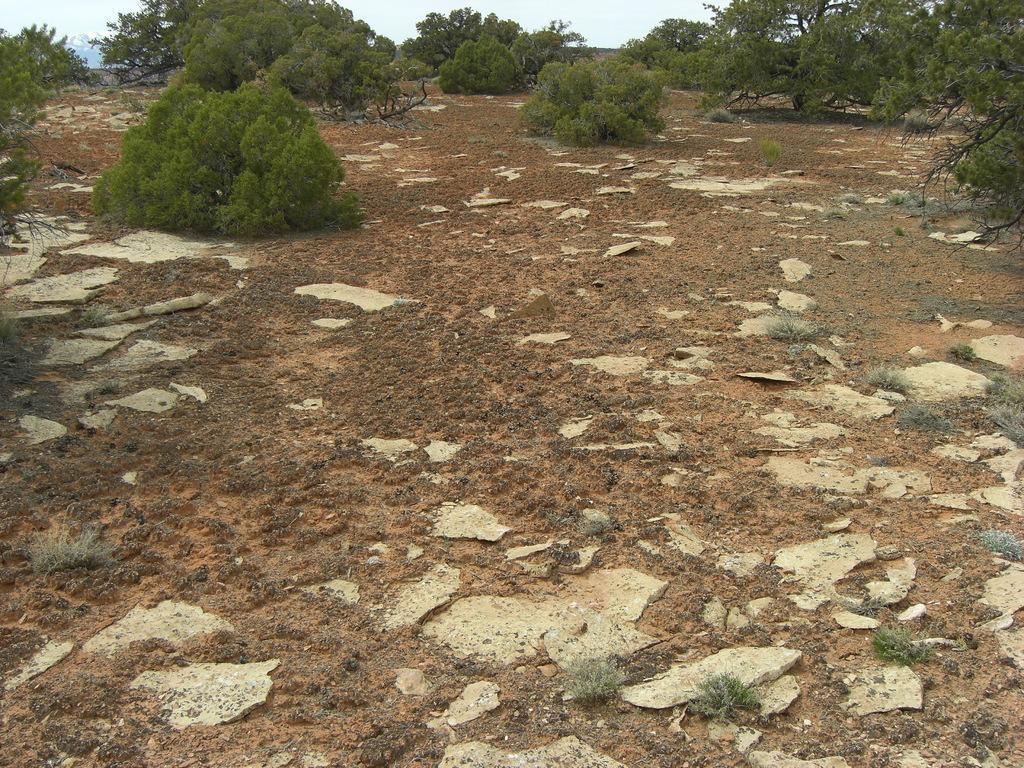Could you give a brief overview of what you see in this image? In this image I can see trees in green color and sky in white color. 